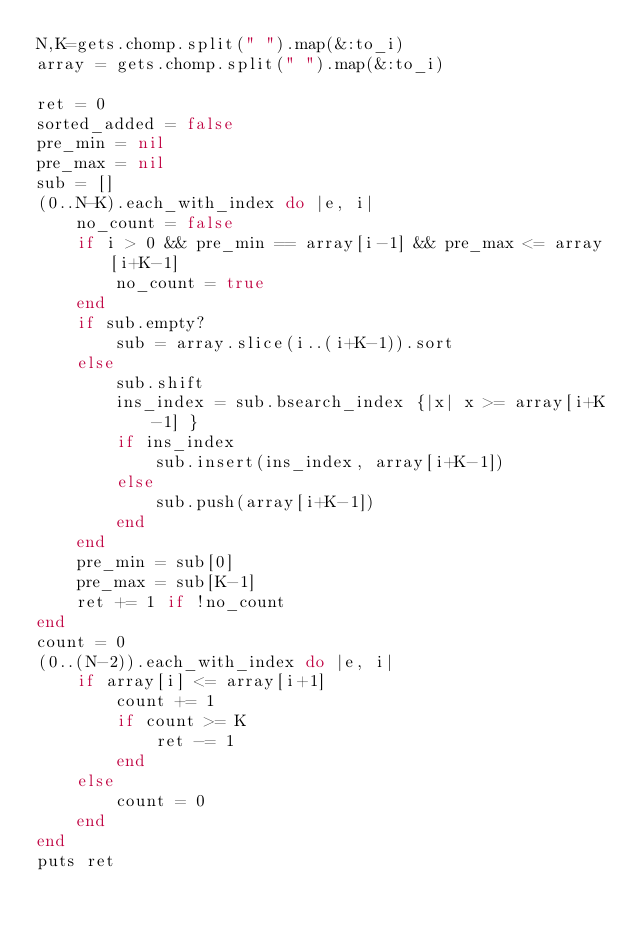Convert code to text. <code><loc_0><loc_0><loc_500><loc_500><_Ruby_>N,K=gets.chomp.split(" ").map(&:to_i)
array = gets.chomp.split(" ").map(&:to_i)

ret = 0
sorted_added = false
pre_min = nil
pre_max = nil
sub = []
(0..N-K).each_with_index do |e, i|
    no_count = false
    if i > 0 && pre_min == array[i-1] && pre_max <= array[i+K-1]
        no_count = true
    end
    if sub.empty?
        sub = array.slice(i..(i+K-1)).sort
    else
        sub.shift
        ins_index = sub.bsearch_index {|x| x >= array[i+K-1] }
        if ins_index
            sub.insert(ins_index, array[i+K-1])
        else
            sub.push(array[i+K-1])
        end
    end
    pre_min = sub[0]
    pre_max = sub[K-1]
    ret += 1 if !no_count
end
count = 0
(0..(N-2)).each_with_index do |e, i|
    if array[i] <= array[i+1]
        count += 1
        if count >= K
            ret -= 1
        end
    else
        count = 0
    end
end
puts ret
</code> 